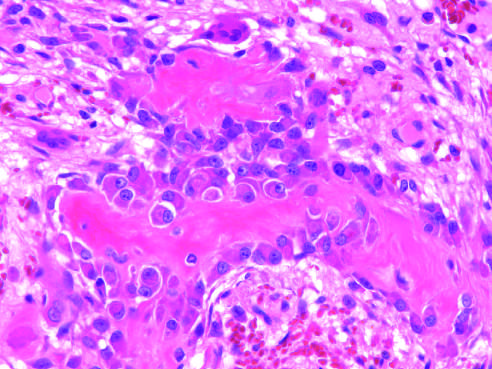do large, flat cells with small nuclei represent osteoprogenitor cells?
Answer the question using a single word or phrase. No 